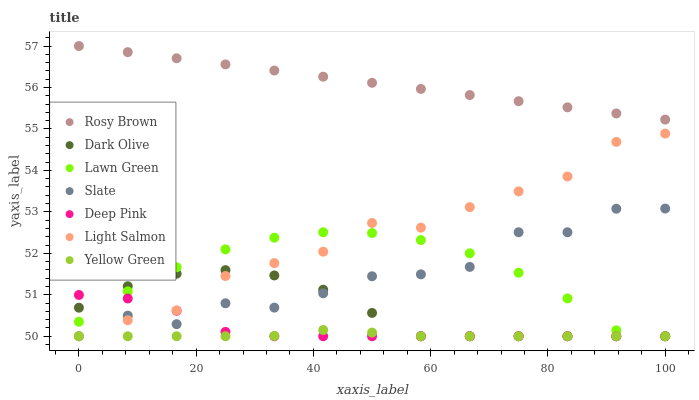Does Yellow Green have the minimum area under the curve?
Answer yes or no. Yes. Does Rosy Brown have the maximum area under the curve?
Answer yes or no. Yes. Does Light Salmon have the minimum area under the curve?
Answer yes or no. No. Does Light Salmon have the maximum area under the curve?
Answer yes or no. No. Is Rosy Brown the smoothest?
Answer yes or no. Yes. Is Slate the roughest?
Answer yes or no. Yes. Is Light Salmon the smoothest?
Answer yes or no. No. Is Light Salmon the roughest?
Answer yes or no. No. Does Lawn Green have the lowest value?
Answer yes or no. Yes. Does Rosy Brown have the lowest value?
Answer yes or no. No. Does Rosy Brown have the highest value?
Answer yes or no. Yes. Does Light Salmon have the highest value?
Answer yes or no. No. Is Deep Pink less than Rosy Brown?
Answer yes or no. Yes. Is Rosy Brown greater than Yellow Green?
Answer yes or no. Yes. Does Deep Pink intersect Light Salmon?
Answer yes or no. Yes. Is Deep Pink less than Light Salmon?
Answer yes or no. No. Is Deep Pink greater than Light Salmon?
Answer yes or no. No. Does Deep Pink intersect Rosy Brown?
Answer yes or no. No. 